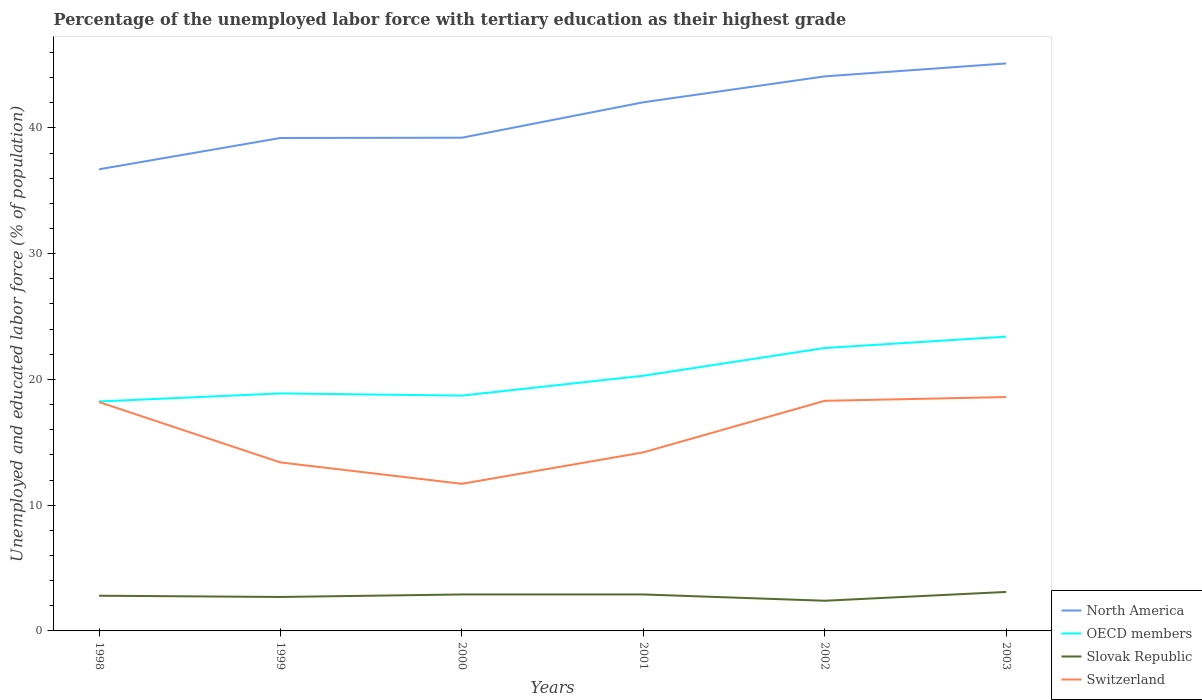How many different coloured lines are there?
Make the answer very short. 4. Does the line corresponding to Slovak Republic intersect with the line corresponding to North America?
Your answer should be very brief. No. Is the number of lines equal to the number of legend labels?
Offer a terse response. Yes. Across all years, what is the maximum percentage of the unemployed labor force with tertiary education in Slovak Republic?
Keep it short and to the point. 2.4. What is the total percentage of the unemployed labor force with tertiary education in North America in the graph?
Your answer should be very brief. -2.82. What is the difference between the highest and the second highest percentage of the unemployed labor force with tertiary education in Slovak Republic?
Provide a short and direct response. 0.7. Is the percentage of the unemployed labor force with tertiary education in Switzerland strictly greater than the percentage of the unemployed labor force with tertiary education in OECD members over the years?
Your answer should be compact. Yes. How many lines are there?
Offer a terse response. 4. Does the graph contain any zero values?
Your answer should be very brief. No. Does the graph contain grids?
Provide a succinct answer. No. How many legend labels are there?
Keep it short and to the point. 4. How are the legend labels stacked?
Your response must be concise. Vertical. What is the title of the graph?
Offer a terse response. Percentage of the unemployed labor force with tertiary education as their highest grade. Does "Cayman Islands" appear as one of the legend labels in the graph?
Provide a succinct answer. No. What is the label or title of the X-axis?
Offer a terse response. Years. What is the label or title of the Y-axis?
Provide a succinct answer. Unemployed and educated labor force (% of population). What is the Unemployed and educated labor force (% of population) in North America in 1998?
Your answer should be compact. 36.71. What is the Unemployed and educated labor force (% of population) in OECD members in 1998?
Give a very brief answer. 18.25. What is the Unemployed and educated labor force (% of population) of Slovak Republic in 1998?
Offer a very short reply. 2.8. What is the Unemployed and educated labor force (% of population) of Switzerland in 1998?
Offer a terse response. 18.2. What is the Unemployed and educated labor force (% of population) of North America in 1999?
Give a very brief answer. 39.2. What is the Unemployed and educated labor force (% of population) in OECD members in 1999?
Offer a terse response. 18.89. What is the Unemployed and educated labor force (% of population) of Slovak Republic in 1999?
Make the answer very short. 2.7. What is the Unemployed and educated labor force (% of population) of Switzerland in 1999?
Make the answer very short. 13.4. What is the Unemployed and educated labor force (% of population) in North America in 2000?
Your answer should be compact. 39.23. What is the Unemployed and educated labor force (% of population) of OECD members in 2000?
Provide a short and direct response. 18.71. What is the Unemployed and educated labor force (% of population) of Slovak Republic in 2000?
Your answer should be very brief. 2.9. What is the Unemployed and educated labor force (% of population) of Switzerland in 2000?
Keep it short and to the point. 11.7. What is the Unemployed and educated labor force (% of population) of North America in 2001?
Offer a very short reply. 42.04. What is the Unemployed and educated labor force (% of population) in OECD members in 2001?
Offer a terse response. 20.29. What is the Unemployed and educated labor force (% of population) of Slovak Republic in 2001?
Offer a very short reply. 2.9. What is the Unemployed and educated labor force (% of population) in Switzerland in 2001?
Keep it short and to the point. 14.2. What is the Unemployed and educated labor force (% of population) of North America in 2002?
Keep it short and to the point. 44.1. What is the Unemployed and educated labor force (% of population) of OECD members in 2002?
Your answer should be compact. 22.5. What is the Unemployed and educated labor force (% of population) in Slovak Republic in 2002?
Offer a terse response. 2.4. What is the Unemployed and educated labor force (% of population) of Switzerland in 2002?
Your answer should be very brief. 18.3. What is the Unemployed and educated labor force (% of population) of North America in 2003?
Ensure brevity in your answer.  45.13. What is the Unemployed and educated labor force (% of population) of OECD members in 2003?
Offer a terse response. 23.4. What is the Unemployed and educated labor force (% of population) in Slovak Republic in 2003?
Make the answer very short. 3.1. What is the Unemployed and educated labor force (% of population) of Switzerland in 2003?
Ensure brevity in your answer.  18.6. Across all years, what is the maximum Unemployed and educated labor force (% of population) of North America?
Ensure brevity in your answer.  45.13. Across all years, what is the maximum Unemployed and educated labor force (% of population) of OECD members?
Provide a short and direct response. 23.4. Across all years, what is the maximum Unemployed and educated labor force (% of population) in Slovak Republic?
Offer a very short reply. 3.1. Across all years, what is the maximum Unemployed and educated labor force (% of population) in Switzerland?
Give a very brief answer. 18.6. Across all years, what is the minimum Unemployed and educated labor force (% of population) in North America?
Keep it short and to the point. 36.71. Across all years, what is the minimum Unemployed and educated labor force (% of population) of OECD members?
Your answer should be very brief. 18.25. Across all years, what is the minimum Unemployed and educated labor force (% of population) of Slovak Republic?
Ensure brevity in your answer.  2.4. Across all years, what is the minimum Unemployed and educated labor force (% of population) in Switzerland?
Offer a very short reply. 11.7. What is the total Unemployed and educated labor force (% of population) of North America in the graph?
Your response must be concise. 246.42. What is the total Unemployed and educated labor force (% of population) in OECD members in the graph?
Your response must be concise. 122.05. What is the total Unemployed and educated labor force (% of population) in Switzerland in the graph?
Your answer should be compact. 94.4. What is the difference between the Unemployed and educated labor force (% of population) in North America in 1998 and that in 1999?
Provide a succinct answer. -2.49. What is the difference between the Unemployed and educated labor force (% of population) in OECD members in 1998 and that in 1999?
Keep it short and to the point. -0.64. What is the difference between the Unemployed and educated labor force (% of population) in Slovak Republic in 1998 and that in 1999?
Provide a succinct answer. 0.1. What is the difference between the Unemployed and educated labor force (% of population) in North America in 1998 and that in 2000?
Your answer should be very brief. -2.51. What is the difference between the Unemployed and educated labor force (% of population) of OECD members in 1998 and that in 2000?
Provide a short and direct response. -0.47. What is the difference between the Unemployed and educated labor force (% of population) in Switzerland in 1998 and that in 2000?
Your answer should be very brief. 6.5. What is the difference between the Unemployed and educated labor force (% of population) of North America in 1998 and that in 2001?
Provide a succinct answer. -5.33. What is the difference between the Unemployed and educated labor force (% of population) in OECD members in 1998 and that in 2001?
Ensure brevity in your answer.  -2.05. What is the difference between the Unemployed and educated labor force (% of population) in Slovak Republic in 1998 and that in 2001?
Your response must be concise. -0.1. What is the difference between the Unemployed and educated labor force (% of population) of Switzerland in 1998 and that in 2001?
Ensure brevity in your answer.  4. What is the difference between the Unemployed and educated labor force (% of population) in North America in 1998 and that in 2002?
Make the answer very short. -7.39. What is the difference between the Unemployed and educated labor force (% of population) of OECD members in 1998 and that in 2002?
Offer a terse response. -4.25. What is the difference between the Unemployed and educated labor force (% of population) of Switzerland in 1998 and that in 2002?
Make the answer very short. -0.1. What is the difference between the Unemployed and educated labor force (% of population) in North America in 1998 and that in 2003?
Your answer should be compact. -8.42. What is the difference between the Unemployed and educated labor force (% of population) in OECD members in 1998 and that in 2003?
Make the answer very short. -5.16. What is the difference between the Unemployed and educated labor force (% of population) in Slovak Republic in 1998 and that in 2003?
Ensure brevity in your answer.  -0.3. What is the difference between the Unemployed and educated labor force (% of population) of North America in 1999 and that in 2000?
Make the answer very short. -0.02. What is the difference between the Unemployed and educated labor force (% of population) in OECD members in 1999 and that in 2000?
Offer a very short reply. 0.17. What is the difference between the Unemployed and educated labor force (% of population) of North America in 1999 and that in 2001?
Your answer should be compact. -2.84. What is the difference between the Unemployed and educated labor force (% of population) in OECD members in 1999 and that in 2001?
Your answer should be compact. -1.41. What is the difference between the Unemployed and educated labor force (% of population) of North America in 1999 and that in 2002?
Your answer should be compact. -4.9. What is the difference between the Unemployed and educated labor force (% of population) of OECD members in 1999 and that in 2002?
Provide a succinct answer. -3.61. What is the difference between the Unemployed and educated labor force (% of population) in Slovak Republic in 1999 and that in 2002?
Your response must be concise. 0.3. What is the difference between the Unemployed and educated labor force (% of population) of North America in 1999 and that in 2003?
Ensure brevity in your answer.  -5.93. What is the difference between the Unemployed and educated labor force (% of population) of OECD members in 1999 and that in 2003?
Keep it short and to the point. -4.51. What is the difference between the Unemployed and educated labor force (% of population) in North America in 2000 and that in 2001?
Keep it short and to the point. -2.82. What is the difference between the Unemployed and educated labor force (% of population) of OECD members in 2000 and that in 2001?
Ensure brevity in your answer.  -1.58. What is the difference between the Unemployed and educated labor force (% of population) of Slovak Republic in 2000 and that in 2001?
Your answer should be very brief. 0. What is the difference between the Unemployed and educated labor force (% of population) of Switzerland in 2000 and that in 2001?
Offer a very short reply. -2.5. What is the difference between the Unemployed and educated labor force (% of population) in North America in 2000 and that in 2002?
Offer a very short reply. -4.88. What is the difference between the Unemployed and educated labor force (% of population) in OECD members in 2000 and that in 2002?
Offer a very short reply. -3.78. What is the difference between the Unemployed and educated labor force (% of population) of Slovak Republic in 2000 and that in 2002?
Make the answer very short. 0.5. What is the difference between the Unemployed and educated labor force (% of population) of North America in 2000 and that in 2003?
Provide a short and direct response. -5.91. What is the difference between the Unemployed and educated labor force (% of population) in OECD members in 2000 and that in 2003?
Provide a succinct answer. -4.69. What is the difference between the Unemployed and educated labor force (% of population) of North America in 2001 and that in 2002?
Offer a terse response. -2.06. What is the difference between the Unemployed and educated labor force (% of population) of OECD members in 2001 and that in 2002?
Ensure brevity in your answer.  -2.2. What is the difference between the Unemployed and educated labor force (% of population) in Slovak Republic in 2001 and that in 2002?
Ensure brevity in your answer.  0.5. What is the difference between the Unemployed and educated labor force (% of population) of Switzerland in 2001 and that in 2002?
Make the answer very short. -4.1. What is the difference between the Unemployed and educated labor force (% of population) in North America in 2001 and that in 2003?
Keep it short and to the point. -3.09. What is the difference between the Unemployed and educated labor force (% of population) in OECD members in 2001 and that in 2003?
Your answer should be very brief. -3.11. What is the difference between the Unemployed and educated labor force (% of population) of Switzerland in 2001 and that in 2003?
Ensure brevity in your answer.  -4.4. What is the difference between the Unemployed and educated labor force (% of population) of North America in 2002 and that in 2003?
Offer a terse response. -1.03. What is the difference between the Unemployed and educated labor force (% of population) of OECD members in 2002 and that in 2003?
Provide a short and direct response. -0.91. What is the difference between the Unemployed and educated labor force (% of population) in North America in 1998 and the Unemployed and educated labor force (% of population) in OECD members in 1999?
Offer a terse response. 17.82. What is the difference between the Unemployed and educated labor force (% of population) of North America in 1998 and the Unemployed and educated labor force (% of population) of Slovak Republic in 1999?
Provide a short and direct response. 34.01. What is the difference between the Unemployed and educated labor force (% of population) of North America in 1998 and the Unemployed and educated labor force (% of population) of Switzerland in 1999?
Provide a short and direct response. 23.31. What is the difference between the Unemployed and educated labor force (% of population) of OECD members in 1998 and the Unemployed and educated labor force (% of population) of Slovak Republic in 1999?
Make the answer very short. 15.55. What is the difference between the Unemployed and educated labor force (% of population) of OECD members in 1998 and the Unemployed and educated labor force (% of population) of Switzerland in 1999?
Your answer should be very brief. 4.85. What is the difference between the Unemployed and educated labor force (% of population) of North America in 1998 and the Unemployed and educated labor force (% of population) of OECD members in 2000?
Your answer should be compact. 18. What is the difference between the Unemployed and educated labor force (% of population) of North America in 1998 and the Unemployed and educated labor force (% of population) of Slovak Republic in 2000?
Ensure brevity in your answer.  33.81. What is the difference between the Unemployed and educated labor force (% of population) in North America in 1998 and the Unemployed and educated labor force (% of population) in Switzerland in 2000?
Provide a succinct answer. 25.01. What is the difference between the Unemployed and educated labor force (% of population) in OECD members in 1998 and the Unemployed and educated labor force (% of population) in Slovak Republic in 2000?
Your answer should be compact. 15.35. What is the difference between the Unemployed and educated labor force (% of population) in OECD members in 1998 and the Unemployed and educated labor force (% of population) in Switzerland in 2000?
Your answer should be very brief. 6.55. What is the difference between the Unemployed and educated labor force (% of population) of Slovak Republic in 1998 and the Unemployed and educated labor force (% of population) of Switzerland in 2000?
Ensure brevity in your answer.  -8.9. What is the difference between the Unemployed and educated labor force (% of population) of North America in 1998 and the Unemployed and educated labor force (% of population) of OECD members in 2001?
Your response must be concise. 16.42. What is the difference between the Unemployed and educated labor force (% of population) of North America in 1998 and the Unemployed and educated labor force (% of population) of Slovak Republic in 2001?
Your response must be concise. 33.81. What is the difference between the Unemployed and educated labor force (% of population) in North America in 1998 and the Unemployed and educated labor force (% of population) in Switzerland in 2001?
Your answer should be very brief. 22.51. What is the difference between the Unemployed and educated labor force (% of population) in OECD members in 1998 and the Unemployed and educated labor force (% of population) in Slovak Republic in 2001?
Provide a short and direct response. 15.35. What is the difference between the Unemployed and educated labor force (% of population) in OECD members in 1998 and the Unemployed and educated labor force (% of population) in Switzerland in 2001?
Ensure brevity in your answer.  4.05. What is the difference between the Unemployed and educated labor force (% of population) of Slovak Republic in 1998 and the Unemployed and educated labor force (% of population) of Switzerland in 2001?
Keep it short and to the point. -11.4. What is the difference between the Unemployed and educated labor force (% of population) in North America in 1998 and the Unemployed and educated labor force (% of population) in OECD members in 2002?
Give a very brief answer. 14.21. What is the difference between the Unemployed and educated labor force (% of population) in North America in 1998 and the Unemployed and educated labor force (% of population) in Slovak Republic in 2002?
Your answer should be very brief. 34.31. What is the difference between the Unemployed and educated labor force (% of population) of North America in 1998 and the Unemployed and educated labor force (% of population) of Switzerland in 2002?
Keep it short and to the point. 18.41. What is the difference between the Unemployed and educated labor force (% of population) in OECD members in 1998 and the Unemployed and educated labor force (% of population) in Slovak Republic in 2002?
Make the answer very short. 15.85. What is the difference between the Unemployed and educated labor force (% of population) of OECD members in 1998 and the Unemployed and educated labor force (% of population) of Switzerland in 2002?
Offer a terse response. -0.05. What is the difference between the Unemployed and educated labor force (% of population) of Slovak Republic in 1998 and the Unemployed and educated labor force (% of population) of Switzerland in 2002?
Your response must be concise. -15.5. What is the difference between the Unemployed and educated labor force (% of population) of North America in 1998 and the Unemployed and educated labor force (% of population) of OECD members in 2003?
Make the answer very short. 13.31. What is the difference between the Unemployed and educated labor force (% of population) of North America in 1998 and the Unemployed and educated labor force (% of population) of Slovak Republic in 2003?
Your response must be concise. 33.61. What is the difference between the Unemployed and educated labor force (% of population) of North America in 1998 and the Unemployed and educated labor force (% of population) of Switzerland in 2003?
Your response must be concise. 18.11. What is the difference between the Unemployed and educated labor force (% of population) in OECD members in 1998 and the Unemployed and educated labor force (% of population) in Slovak Republic in 2003?
Give a very brief answer. 15.15. What is the difference between the Unemployed and educated labor force (% of population) of OECD members in 1998 and the Unemployed and educated labor force (% of population) of Switzerland in 2003?
Give a very brief answer. -0.35. What is the difference between the Unemployed and educated labor force (% of population) of Slovak Republic in 1998 and the Unemployed and educated labor force (% of population) of Switzerland in 2003?
Offer a very short reply. -15.8. What is the difference between the Unemployed and educated labor force (% of population) in North America in 1999 and the Unemployed and educated labor force (% of population) in OECD members in 2000?
Offer a very short reply. 20.49. What is the difference between the Unemployed and educated labor force (% of population) in North America in 1999 and the Unemployed and educated labor force (% of population) in Slovak Republic in 2000?
Your answer should be very brief. 36.3. What is the difference between the Unemployed and educated labor force (% of population) of North America in 1999 and the Unemployed and educated labor force (% of population) of Switzerland in 2000?
Your response must be concise. 27.5. What is the difference between the Unemployed and educated labor force (% of population) of OECD members in 1999 and the Unemployed and educated labor force (% of population) of Slovak Republic in 2000?
Make the answer very short. 15.99. What is the difference between the Unemployed and educated labor force (% of population) in OECD members in 1999 and the Unemployed and educated labor force (% of population) in Switzerland in 2000?
Ensure brevity in your answer.  7.19. What is the difference between the Unemployed and educated labor force (% of population) in North America in 1999 and the Unemployed and educated labor force (% of population) in OECD members in 2001?
Provide a short and direct response. 18.91. What is the difference between the Unemployed and educated labor force (% of population) in North America in 1999 and the Unemployed and educated labor force (% of population) in Slovak Republic in 2001?
Your response must be concise. 36.3. What is the difference between the Unemployed and educated labor force (% of population) of North America in 1999 and the Unemployed and educated labor force (% of population) of Switzerland in 2001?
Provide a short and direct response. 25. What is the difference between the Unemployed and educated labor force (% of population) of OECD members in 1999 and the Unemployed and educated labor force (% of population) of Slovak Republic in 2001?
Provide a short and direct response. 15.99. What is the difference between the Unemployed and educated labor force (% of population) of OECD members in 1999 and the Unemployed and educated labor force (% of population) of Switzerland in 2001?
Offer a very short reply. 4.69. What is the difference between the Unemployed and educated labor force (% of population) in Slovak Republic in 1999 and the Unemployed and educated labor force (% of population) in Switzerland in 2001?
Keep it short and to the point. -11.5. What is the difference between the Unemployed and educated labor force (% of population) in North America in 1999 and the Unemployed and educated labor force (% of population) in OECD members in 2002?
Provide a succinct answer. 16.7. What is the difference between the Unemployed and educated labor force (% of population) of North America in 1999 and the Unemployed and educated labor force (% of population) of Slovak Republic in 2002?
Keep it short and to the point. 36.8. What is the difference between the Unemployed and educated labor force (% of population) of North America in 1999 and the Unemployed and educated labor force (% of population) of Switzerland in 2002?
Provide a succinct answer. 20.9. What is the difference between the Unemployed and educated labor force (% of population) in OECD members in 1999 and the Unemployed and educated labor force (% of population) in Slovak Republic in 2002?
Your answer should be very brief. 16.49. What is the difference between the Unemployed and educated labor force (% of population) in OECD members in 1999 and the Unemployed and educated labor force (% of population) in Switzerland in 2002?
Offer a terse response. 0.59. What is the difference between the Unemployed and educated labor force (% of population) of Slovak Republic in 1999 and the Unemployed and educated labor force (% of population) of Switzerland in 2002?
Provide a succinct answer. -15.6. What is the difference between the Unemployed and educated labor force (% of population) of North America in 1999 and the Unemployed and educated labor force (% of population) of OECD members in 2003?
Give a very brief answer. 15.8. What is the difference between the Unemployed and educated labor force (% of population) in North America in 1999 and the Unemployed and educated labor force (% of population) in Slovak Republic in 2003?
Give a very brief answer. 36.1. What is the difference between the Unemployed and educated labor force (% of population) of North America in 1999 and the Unemployed and educated labor force (% of population) of Switzerland in 2003?
Provide a short and direct response. 20.6. What is the difference between the Unemployed and educated labor force (% of population) of OECD members in 1999 and the Unemployed and educated labor force (% of population) of Slovak Republic in 2003?
Offer a very short reply. 15.79. What is the difference between the Unemployed and educated labor force (% of population) in OECD members in 1999 and the Unemployed and educated labor force (% of population) in Switzerland in 2003?
Offer a very short reply. 0.29. What is the difference between the Unemployed and educated labor force (% of population) of Slovak Republic in 1999 and the Unemployed and educated labor force (% of population) of Switzerland in 2003?
Keep it short and to the point. -15.9. What is the difference between the Unemployed and educated labor force (% of population) in North America in 2000 and the Unemployed and educated labor force (% of population) in OECD members in 2001?
Ensure brevity in your answer.  18.93. What is the difference between the Unemployed and educated labor force (% of population) in North America in 2000 and the Unemployed and educated labor force (% of population) in Slovak Republic in 2001?
Offer a terse response. 36.33. What is the difference between the Unemployed and educated labor force (% of population) in North America in 2000 and the Unemployed and educated labor force (% of population) in Switzerland in 2001?
Your answer should be very brief. 25.03. What is the difference between the Unemployed and educated labor force (% of population) in OECD members in 2000 and the Unemployed and educated labor force (% of population) in Slovak Republic in 2001?
Offer a very short reply. 15.81. What is the difference between the Unemployed and educated labor force (% of population) of OECD members in 2000 and the Unemployed and educated labor force (% of population) of Switzerland in 2001?
Your answer should be very brief. 4.51. What is the difference between the Unemployed and educated labor force (% of population) in North America in 2000 and the Unemployed and educated labor force (% of population) in OECD members in 2002?
Provide a succinct answer. 16.73. What is the difference between the Unemployed and educated labor force (% of population) of North America in 2000 and the Unemployed and educated labor force (% of population) of Slovak Republic in 2002?
Provide a succinct answer. 36.83. What is the difference between the Unemployed and educated labor force (% of population) in North America in 2000 and the Unemployed and educated labor force (% of population) in Switzerland in 2002?
Your answer should be compact. 20.93. What is the difference between the Unemployed and educated labor force (% of population) in OECD members in 2000 and the Unemployed and educated labor force (% of population) in Slovak Republic in 2002?
Offer a very short reply. 16.31. What is the difference between the Unemployed and educated labor force (% of population) of OECD members in 2000 and the Unemployed and educated labor force (% of population) of Switzerland in 2002?
Your answer should be compact. 0.41. What is the difference between the Unemployed and educated labor force (% of population) in Slovak Republic in 2000 and the Unemployed and educated labor force (% of population) in Switzerland in 2002?
Make the answer very short. -15.4. What is the difference between the Unemployed and educated labor force (% of population) in North America in 2000 and the Unemployed and educated labor force (% of population) in OECD members in 2003?
Your response must be concise. 15.82. What is the difference between the Unemployed and educated labor force (% of population) of North America in 2000 and the Unemployed and educated labor force (% of population) of Slovak Republic in 2003?
Your answer should be compact. 36.13. What is the difference between the Unemployed and educated labor force (% of population) of North America in 2000 and the Unemployed and educated labor force (% of population) of Switzerland in 2003?
Provide a succinct answer. 20.63. What is the difference between the Unemployed and educated labor force (% of population) of OECD members in 2000 and the Unemployed and educated labor force (% of population) of Slovak Republic in 2003?
Offer a terse response. 15.61. What is the difference between the Unemployed and educated labor force (% of population) in OECD members in 2000 and the Unemployed and educated labor force (% of population) in Switzerland in 2003?
Provide a succinct answer. 0.11. What is the difference between the Unemployed and educated labor force (% of population) of Slovak Republic in 2000 and the Unemployed and educated labor force (% of population) of Switzerland in 2003?
Provide a short and direct response. -15.7. What is the difference between the Unemployed and educated labor force (% of population) of North America in 2001 and the Unemployed and educated labor force (% of population) of OECD members in 2002?
Your answer should be compact. 19.54. What is the difference between the Unemployed and educated labor force (% of population) of North America in 2001 and the Unemployed and educated labor force (% of population) of Slovak Republic in 2002?
Make the answer very short. 39.64. What is the difference between the Unemployed and educated labor force (% of population) in North America in 2001 and the Unemployed and educated labor force (% of population) in Switzerland in 2002?
Give a very brief answer. 23.74. What is the difference between the Unemployed and educated labor force (% of population) of OECD members in 2001 and the Unemployed and educated labor force (% of population) of Slovak Republic in 2002?
Ensure brevity in your answer.  17.89. What is the difference between the Unemployed and educated labor force (% of population) of OECD members in 2001 and the Unemployed and educated labor force (% of population) of Switzerland in 2002?
Your answer should be very brief. 1.99. What is the difference between the Unemployed and educated labor force (% of population) in Slovak Republic in 2001 and the Unemployed and educated labor force (% of population) in Switzerland in 2002?
Offer a very short reply. -15.4. What is the difference between the Unemployed and educated labor force (% of population) of North America in 2001 and the Unemployed and educated labor force (% of population) of OECD members in 2003?
Ensure brevity in your answer.  18.64. What is the difference between the Unemployed and educated labor force (% of population) in North America in 2001 and the Unemployed and educated labor force (% of population) in Slovak Republic in 2003?
Provide a short and direct response. 38.94. What is the difference between the Unemployed and educated labor force (% of population) of North America in 2001 and the Unemployed and educated labor force (% of population) of Switzerland in 2003?
Provide a succinct answer. 23.44. What is the difference between the Unemployed and educated labor force (% of population) of OECD members in 2001 and the Unemployed and educated labor force (% of population) of Slovak Republic in 2003?
Give a very brief answer. 17.19. What is the difference between the Unemployed and educated labor force (% of population) of OECD members in 2001 and the Unemployed and educated labor force (% of population) of Switzerland in 2003?
Provide a short and direct response. 1.69. What is the difference between the Unemployed and educated labor force (% of population) of Slovak Republic in 2001 and the Unemployed and educated labor force (% of population) of Switzerland in 2003?
Provide a succinct answer. -15.7. What is the difference between the Unemployed and educated labor force (% of population) in North America in 2002 and the Unemployed and educated labor force (% of population) in OECD members in 2003?
Ensure brevity in your answer.  20.7. What is the difference between the Unemployed and educated labor force (% of population) of North America in 2002 and the Unemployed and educated labor force (% of population) of Slovak Republic in 2003?
Offer a terse response. 41. What is the difference between the Unemployed and educated labor force (% of population) in North America in 2002 and the Unemployed and educated labor force (% of population) in Switzerland in 2003?
Give a very brief answer. 25.5. What is the difference between the Unemployed and educated labor force (% of population) of OECD members in 2002 and the Unemployed and educated labor force (% of population) of Slovak Republic in 2003?
Give a very brief answer. 19.4. What is the difference between the Unemployed and educated labor force (% of population) in OECD members in 2002 and the Unemployed and educated labor force (% of population) in Switzerland in 2003?
Your answer should be very brief. 3.9. What is the difference between the Unemployed and educated labor force (% of population) of Slovak Republic in 2002 and the Unemployed and educated labor force (% of population) of Switzerland in 2003?
Make the answer very short. -16.2. What is the average Unemployed and educated labor force (% of population) in North America per year?
Provide a short and direct response. 41.07. What is the average Unemployed and educated labor force (% of population) in OECD members per year?
Give a very brief answer. 20.34. What is the average Unemployed and educated labor force (% of population) in Slovak Republic per year?
Offer a terse response. 2.8. What is the average Unemployed and educated labor force (% of population) of Switzerland per year?
Your answer should be very brief. 15.73. In the year 1998, what is the difference between the Unemployed and educated labor force (% of population) in North America and Unemployed and educated labor force (% of population) in OECD members?
Your answer should be compact. 18.46. In the year 1998, what is the difference between the Unemployed and educated labor force (% of population) of North America and Unemployed and educated labor force (% of population) of Slovak Republic?
Your answer should be very brief. 33.91. In the year 1998, what is the difference between the Unemployed and educated labor force (% of population) in North America and Unemployed and educated labor force (% of population) in Switzerland?
Offer a terse response. 18.51. In the year 1998, what is the difference between the Unemployed and educated labor force (% of population) of OECD members and Unemployed and educated labor force (% of population) of Slovak Republic?
Ensure brevity in your answer.  15.45. In the year 1998, what is the difference between the Unemployed and educated labor force (% of population) in OECD members and Unemployed and educated labor force (% of population) in Switzerland?
Give a very brief answer. 0.05. In the year 1998, what is the difference between the Unemployed and educated labor force (% of population) in Slovak Republic and Unemployed and educated labor force (% of population) in Switzerland?
Ensure brevity in your answer.  -15.4. In the year 1999, what is the difference between the Unemployed and educated labor force (% of population) of North America and Unemployed and educated labor force (% of population) of OECD members?
Keep it short and to the point. 20.31. In the year 1999, what is the difference between the Unemployed and educated labor force (% of population) in North America and Unemployed and educated labor force (% of population) in Slovak Republic?
Provide a short and direct response. 36.5. In the year 1999, what is the difference between the Unemployed and educated labor force (% of population) of North America and Unemployed and educated labor force (% of population) of Switzerland?
Keep it short and to the point. 25.8. In the year 1999, what is the difference between the Unemployed and educated labor force (% of population) of OECD members and Unemployed and educated labor force (% of population) of Slovak Republic?
Offer a very short reply. 16.19. In the year 1999, what is the difference between the Unemployed and educated labor force (% of population) of OECD members and Unemployed and educated labor force (% of population) of Switzerland?
Your response must be concise. 5.49. In the year 2000, what is the difference between the Unemployed and educated labor force (% of population) in North America and Unemployed and educated labor force (% of population) in OECD members?
Offer a terse response. 20.51. In the year 2000, what is the difference between the Unemployed and educated labor force (% of population) in North America and Unemployed and educated labor force (% of population) in Slovak Republic?
Keep it short and to the point. 36.33. In the year 2000, what is the difference between the Unemployed and educated labor force (% of population) in North America and Unemployed and educated labor force (% of population) in Switzerland?
Your answer should be very brief. 27.53. In the year 2000, what is the difference between the Unemployed and educated labor force (% of population) in OECD members and Unemployed and educated labor force (% of population) in Slovak Republic?
Offer a terse response. 15.81. In the year 2000, what is the difference between the Unemployed and educated labor force (% of population) in OECD members and Unemployed and educated labor force (% of population) in Switzerland?
Keep it short and to the point. 7.01. In the year 2001, what is the difference between the Unemployed and educated labor force (% of population) in North America and Unemployed and educated labor force (% of population) in OECD members?
Offer a terse response. 21.75. In the year 2001, what is the difference between the Unemployed and educated labor force (% of population) in North America and Unemployed and educated labor force (% of population) in Slovak Republic?
Provide a succinct answer. 39.14. In the year 2001, what is the difference between the Unemployed and educated labor force (% of population) in North America and Unemployed and educated labor force (% of population) in Switzerland?
Your answer should be compact. 27.84. In the year 2001, what is the difference between the Unemployed and educated labor force (% of population) of OECD members and Unemployed and educated labor force (% of population) of Slovak Republic?
Keep it short and to the point. 17.39. In the year 2001, what is the difference between the Unemployed and educated labor force (% of population) in OECD members and Unemployed and educated labor force (% of population) in Switzerland?
Make the answer very short. 6.09. In the year 2001, what is the difference between the Unemployed and educated labor force (% of population) of Slovak Republic and Unemployed and educated labor force (% of population) of Switzerland?
Your answer should be very brief. -11.3. In the year 2002, what is the difference between the Unemployed and educated labor force (% of population) of North America and Unemployed and educated labor force (% of population) of OECD members?
Your answer should be compact. 21.6. In the year 2002, what is the difference between the Unemployed and educated labor force (% of population) of North America and Unemployed and educated labor force (% of population) of Slovak Republic?
Offer a terse response. 41.7. In the year 2002, what is the difference between the Unemployed and educated labor force (% of population) in North America and Unemployed and educated labor force (% of population) in Switzerland?
Your answer should be very brief. 25.8. In the year 2002, what is the difference between the Unemployed and educated labor force (% of population) of OECD members and Unemployed and educated labor force (% of population) of Slovak Republic?
Offer a very short reply. 20.1. In the year 2002, what is the difference between the Unemployed and educated labor force (% of population) of OECD members and Unemployed and educated labor force (% of population) of Switzerland?
Your answer should be compact. 4.2. In the year 2002, what is the difference between the Unemployed and educated labor force (% of population) of Slovak Republic and Unemployed and educated labor force (% of population) of Switzerland?
Ensure brevity in your answer.  -15.9. In the year 2003, what is the difference between the Unemployed and educated labor force (% of population) of North America and Unemployed and educated labor force (% of population) of OECD members?
Provide a succinct answer. 21.73. In the year 2003, what is the difference between the Unemployed and educated labor force (% of population) in North America and Unemployed and educated labor force (% of population) in Slovak Republic?
Provide a succinct answer. 42.03. In the year 2003, what is the difference between the Unemployed and educated labor force (% of population) of North America and Unemployed and educated labor force (% of population) of Switzerland?
Provide a succinct answer. 26.53. In the year 2003, what is the difference between the Unemployed and educated labor force (% of population) in OECD members and Unemployed and educated labor force (% of population) in Slovak Republic?
Your answer should be compact. 20.3. In the year 2003, what is the difference between the Unemployed and educated labor force (% of population) of OECD members and Unemployed and educated labor force (% of population) of Switzerland?
Provide a succinct answer. 4.8. In the year 2003, what is the difference between the Unemployed and educated labor force (% of population) of Slovak Republic and Unemployed and educated labor force (% of population) of Switzerland?
Offer a terse response. -15.5. What is the ratio of the Unemployed and educated labor force (% of population) in North America in 1998 to that in 1999?
Your answer should be compact. 0.94. What is the ratio of the Unemployed and educated labor force (% of population) in OECD members in 1998 to that in 1999?
Keep it short and to the point. 0.97. What is the ratio of the Unemployed and educated labor force (% of population) of Switzerland in 1998 to that in 1999?
Your answer should be very brief. 1.36. What is the ratio of the Unemployed and educated labor force (% of population) of North America in 1998 to that in 2000?
Keep it short and to the point. 0.94. What is the ratio of the Unemployed and educated labor force (% of population) in OECD members in 1998 to that in 2000?
Provide a short and direct response. 0.98. What is the ratio of the Unemployed and educated labor force (% of population) of Slovak Republic in 1998 to that in 2000?
Give a very brief answer. 0.97. What is the ratio of the Unemployed and educated labor force (% of population) in Switzerland in 1998 to that in 2000?
Your response must be concise. 1.56. What is the ratio of the Unemployed and educated labor force (% of population) in North America in 1998 to that in 2001?
Make the answer very short. 0.87. What is the ratio of the Unemployed and educated labor force (% of population) of OECD members in 1998 to that in 2001?
Provide a short and direct response. 0.9. What is the ratio of the Unemployed and educated labor force (% of population) in Slovak Republic in 1998 to that in 2001?
Make the answer very short. 0.97. What is the ratio of the Unemployed and educated labor force (% of population) in Switzerland in 1998 to that in 2001?
Provide a succinct answer. 1.28. What is the ratio of the Unemployed and educated labor force (% of population) of North America in 1998 to that in 2002?
Your answer should be compact. 0.83. What is the ratio of the Unemployed and educated labor force (% of population) of OECD members in 1998 to that in 2002?
Make the answer very short. 0.81. What is the ratio of the Unemployed and educated labor force (% of population) in Slovak Republic in 1998 to that in 2002?
Keep it short and to the point. 1.17. What is the ratio of the Unemployed and educated labor force (% of population) in North America in 1998 to that in 2003?
Offer a very short reply. 0.81. What is the ratio of the Unemployed and educated labor force (% of population) in OECD members in 1998 to that in 2003?
Offer a terse response. 0.78. What is the ratio of the Unemployed and educated labor force (% of population) in Slovak Republic in 1998 to that in 2003?
Offer a terse response. 0.9. What is the ratio of the Unemployed and educated labor force (% of population) of Switzerland in 1998 to that in 2003?
Ensure brevity in your answer.  0.98. What is the ratio of the Unemployed and educated labor force (% of population) of North America in 1999 to that in 2000?
Your answer should be very brief. 1. What is the ratio of the Unemployed and educated labor force (% of population) in OECD members in 1999 to that in 2000?
Give a very brief answer. 1.01. What is the ratio of the Unemployed and educated labor force (% of population) of Slovak Republic in 1999 to that in 2000?
Give a very brief answer. 0.93. What is the ratio of the Unemployed and educated labor force (% of population) in Switzerland in 1999 to that in 2000?
Offer a terse response. 1.15. What is the ratio of the Unemployed and educated labor force (% of population) of North America in 1999 to that in 2001?
Provide a succinct answer. 0.93. What is the ratio of the Unemployed and educated labor force (% of population) in OECD members in 1999 to that in 2001?
Your answer should be compact. 0.93. What is the ratio of the Unemployed and educated labor force (% of population) in Switzerland in 1999 to that in 2001?
Keep it short and to the point. 0.94. What is the ratio of the Unemployed and educated labor force (% of population) in North America in 1999 to that in 2002?
Provide a short and direct response. 0.89. What is the ratio of the Unemployed and educated labor force (% of population) in OECD members in 1999 to that in 2002?
Provide a short and direct response. 0.84. What is the ratio of the Unemployed and educated labor force (% of population) of Switzerland in 1999 to that in 2002?
Your answer should be compact. 0.73. What is the ratio of the Unemployed and educated labor force (% of population) in North America in 1999 to that in 2003?
Provide a short and direct response. 0.87. What is the ratio of the Unemployed and educated labor force (% of population) of OECD members in 1999 to that in 2003?
Keep it short and to the point. 0.81. What is the ratio of the Unemployed and educated labor force (% of population) in Slovak Republic in 1999 to that in 2003?
Ensure brevity in your answer.  0.87. What is the ratio of the Unemployed and educated labor force (% of population) of Switzerland in 1999 to that in 2003?
Offer a terse response. 0.72. What is the ratio of the Unemployed and educated labor force (% of population) of North America in 2000 to that in 2001?
Make the answer very short. 0.93. What is the ratio of the Unemployed and educated labor force (% of population) of OECD members in 2000 to that in 2001?
Provide a succinct answer. 0.92. What is the ratio of the Unemployed and educated labor force (% of population) in Slovak Republic in 2000 to that in 2001?
Keep it short and to the point. 1. What is the ratio of the Unemployed and educated labor force (% of population) in Switzerland in 2000 to that in 2001?
Your response must be concise. 0.82. What is the ratio of the Unemployed and educated labor force (% of population) in North America in 2000 to that in 2002?
Ensure brevity in your answer.  0.89. What is the ratio of the Unemployed and educated labor force (% of population) of OECD members in 2000 to that in 2002?
Give a very brief answer. 0.83. What is the ratio of the Unemployed and educated labor force (% of population) of Slovak Republic in 2000 to that in 2002?
Your answer should be very brief. 1.21. What is the ratio of the Unemployed and educated labor force (% of population) of Switzerland in 2000 to that in 2002?
Keep it short and to the point. 0.64. What is the ratio of the Unemployed and educated labor force (% of population) in North America in 2000 to that in 2003?
Your response must be concise. 0.87. What is the ratio of the Unemployed and educated labor force (% of population) in OECD members in 2000 to that in 2003?
Offer a very short reply. 0.8. What is the ratio of the Unemployed and educated labor force (% of population) of Slovak Republic in 2000 to that in 2003?
Make the answer very short. 0.94. What is the ratio of the Unemployed and educated labor force (% of population) of Switzerland in 2000 to that in 2003?
Make the answer very short. 0.63. What is the ratio of the Unemployed and educated labor force (% of population) in North America in 2001 to that in 2002?
Your response must be concise. 0.95. What is the ratio of the Unemployed and educated labor force (% of population) of OECD members in 2001 to that in 2002?
Offer a very short reply. 0.9. What is the ratio of the Unemployed and educated labor force (% of population) in Slovak Republic in 2001 to that in 2002?
Offer a terse response. 1.21. What is the ratio of the Unemployed and educated labor force (% of population) of Switzerland in 2001 to that in 2002?
Your answer should be very brief. 0.78. What is the ratio of the Unemployed and educated labor force (% of population) in North America in 2001 to that in 2003?
Provide a short and direct response. 0.93. What is the ratio of the Unemployed and educated labor force (% of population) in OECD members in 2001 to that in 2003?
Your response must be concise. 0.87. What is the ratio of the Unemployed and educated labor force (% of population) of Slovak Republic in 2001 to that in 2003?
Ensure brevity in your answer.  0.94. What is the ratio of the Unemployed and educated labor force (% of population) of Switzerland in 2001 to that in 2003?
Provide a succinct answer. 0.76. What is the ratio of the Unemployed and educated labor force (% of population) of North America in 2002 to that in 2003?
Offer a terse response. 0.98. What is the ratio of the Unemployed and educated labor force (% of population) in OECD members in 2002 to that in 2003?
Make the answer very short. 0.96. What is the ratio of the Unemployed and educated labor force (% of population) in Slovak Republic in 2002 to that in 2003?
Your answer should be very brief. 0.77. What is the ratio of the Unemployed and educated labor force (% of population) in Switzerland in 2002 to that in 2003?
Make the answer very short. 0.98. What is the difference between the highest and the second highest Unemployed and educated labor force (% of population) in North America?
Your answer should be very brief. 1.03. What is the difference between the highest and the second highest Unemployed and educated labor force (% of population) of OECD members?
Make the answer very short. 0.91. What is the difference between the highest and the second highest Unemployed and educated labor force (% of population) in Switzerland?
Your answer should be compact. 0.3. What is the difference between the highest and the lowest Unemployed and educated labor force (% of population) in North America?
Offer a very short reply. 8.42. What is the difference between the highest and the lowest Unemployed and educated labor force (% of population) of OECD members?
Your answer should be compact. 5.16. What is the difference between the highest and the lowest Unemployed and educated labor force (% of population) of Slovak Republic?
Your answer should be compact. 0.7. 